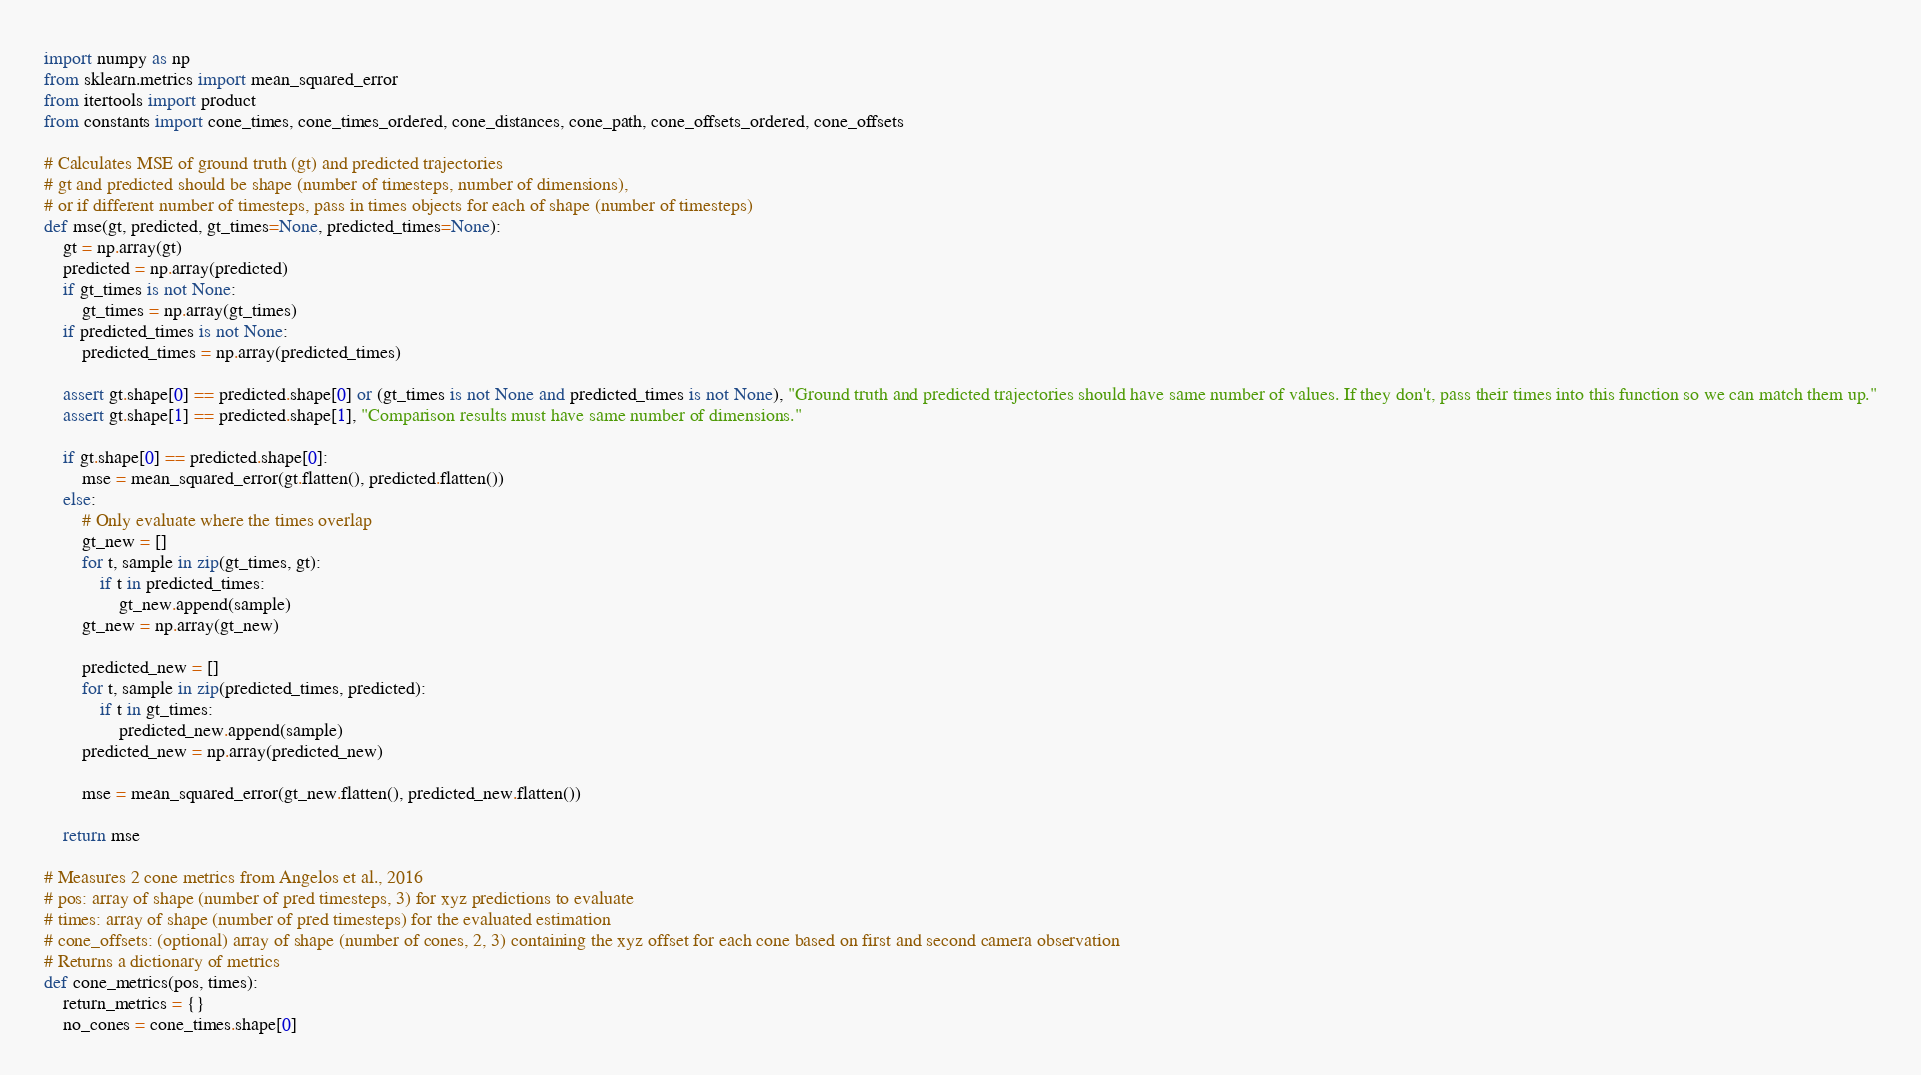Convert code to text. <code><loc_0><loc_0><loc_500><loc_500><_Python_>import numpy as np
from sklearn.metrics import mean_squared_error
from itertools import product
from constants import cone_times, cone_times_ordered, cone_distances, cone_path, cone_offsets_ordered, cone_offsets

# Calculates MSE of ground truth (gt) and predicted trajectories
# gt and predicted should be shape (number of timesteps, number of dimensions),
# or if different number of timesteps, pass in times objects for each of shape (number of timesteps)
def mse(gt, predicted, gt_times=None, predicted_times=None):
    gt = np.array(gt)
    predicted = np.array(predicted)
    if gt_times is not None:
        gt_times = np.array(gt_times)
    if predicted_times is not None:
        predicted_times = np.array(predicted_times)

    assert gt.shape[0] == predicted.shape[0] or (gt_times is not None and predicted_times is not None), "Ground truth and predicted trajectories should have same number of values. If they don't, pass their times into this function so we can match them up."
    assert gt.shape[1] == predicted.shape[1], "Comparison results must have same number of dimensions."

    if gt.shape[0] == predicted.shape[0]:
        mse = mean_squared_error(gt.flatten(), predicted.flatten())
    else:
        # Only evaluate where the times overlap
        gt_new = []
        for t, sample in zip(gt_times, gt):
            if t in predicted_times:
                gt_new.append(sample)
        gt_new = np.array(gt_new)

        predicted_new = []
        for t, sample in zip(predicted_times, predicted):
            if t in gt_times:
                predicted_new.append(sample)
        predicted_new = np.array(predicted_new)

        mse = mean_squared_error(gt_new.flatten(), predicted_new.flatten())

    return mse

# Measures 2 cone metrics from Angelos et al., 2016
# pos: array of shape (number of pred timesteps, 3) for xyz predictions to evaluate
# times: array of shape (number of pred timesteps) for the evaluated estimation
# cone_offsets: (optional) array of shape (number of cones, 2, 3) containing the xyz offset for each cone based on first and second camera observation
# Returns a dictionary of metrics
def cone_metrics(pos, times):
    return_metrics = {}
    no_cones = cone_times.shape[0]</code> 